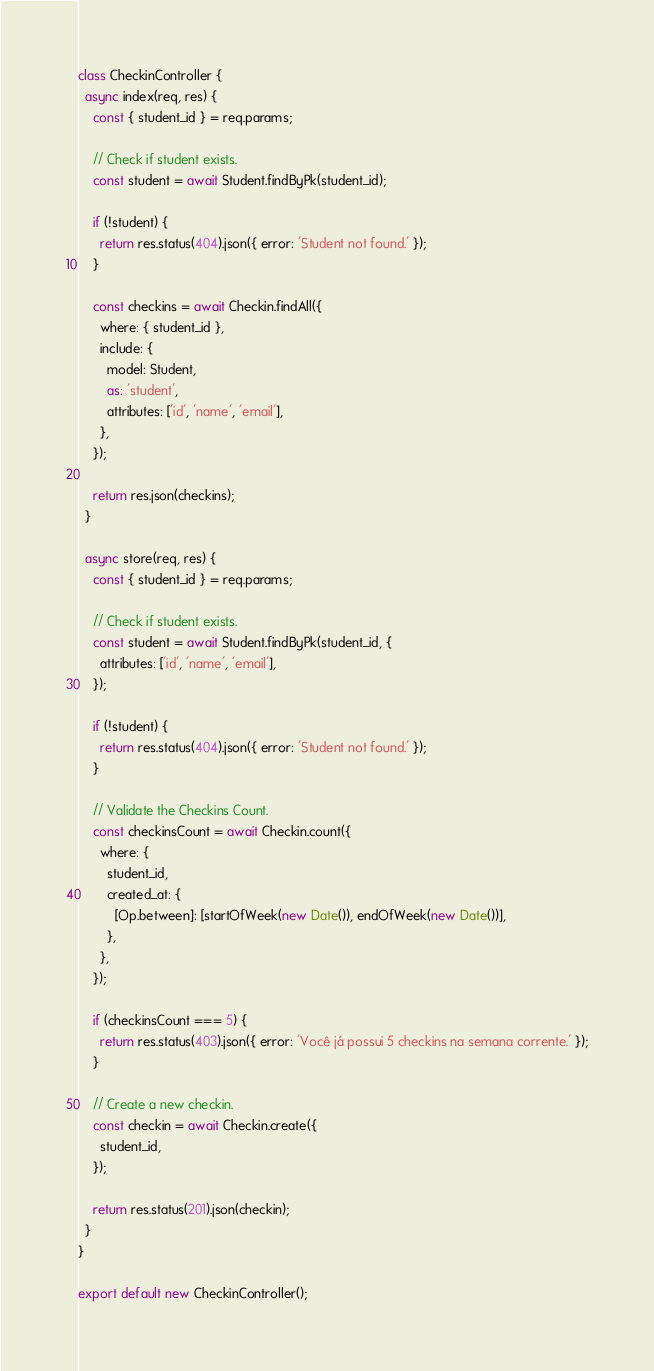Convert code to text. <code><loc_0><loc_0><loc_500><loc_500><_JavaScript_>
class CheckinController {
  async index(req, res) {
    const { student_id } = req.params;

    // Check if student exists.
    const student = await Student.findByPk(student_id);

    if (!student) {
      return res.status(404).json({ error: 'Student not found.' });
    }

    const checkins = await Checkin.findAll({
      where: { student_id },
      include: {
        model: Student,
        as: 'student',
        attributes: ['id', 'name', 'email'],
      },
    });

    return res.json(checkins);
  }

  async store(req, res) {
    const { student_id } = req.params;

    // Check if student exists.
    const student = await Student.findByPk(student_id, {
      attributes: ['id', 'name', 'email'],
    });

    if (!student) {
      return res.status(404).json({ error: 'Student not found.' });
    }

    // Validate the Checkins Count.
    const checkinsCount = await Checkin.count({
      where: {
        student_id,
        created_at: {
          [Op.between]: [startOfWeek(new Date()), endOfWeek(new Date())],
        },
      },
    });

    if (checkinsCount === 5) {
      return res.status(403).json({ error: 'Você já possui 5 checkins na semana corrente.' });
    }

    // Create a new checkin.
    const checkin = await Checkin.create({
      student_id,
    });

    return res.status(201).json(checkin);
  }
}

export default new CheckinController();
</code> 